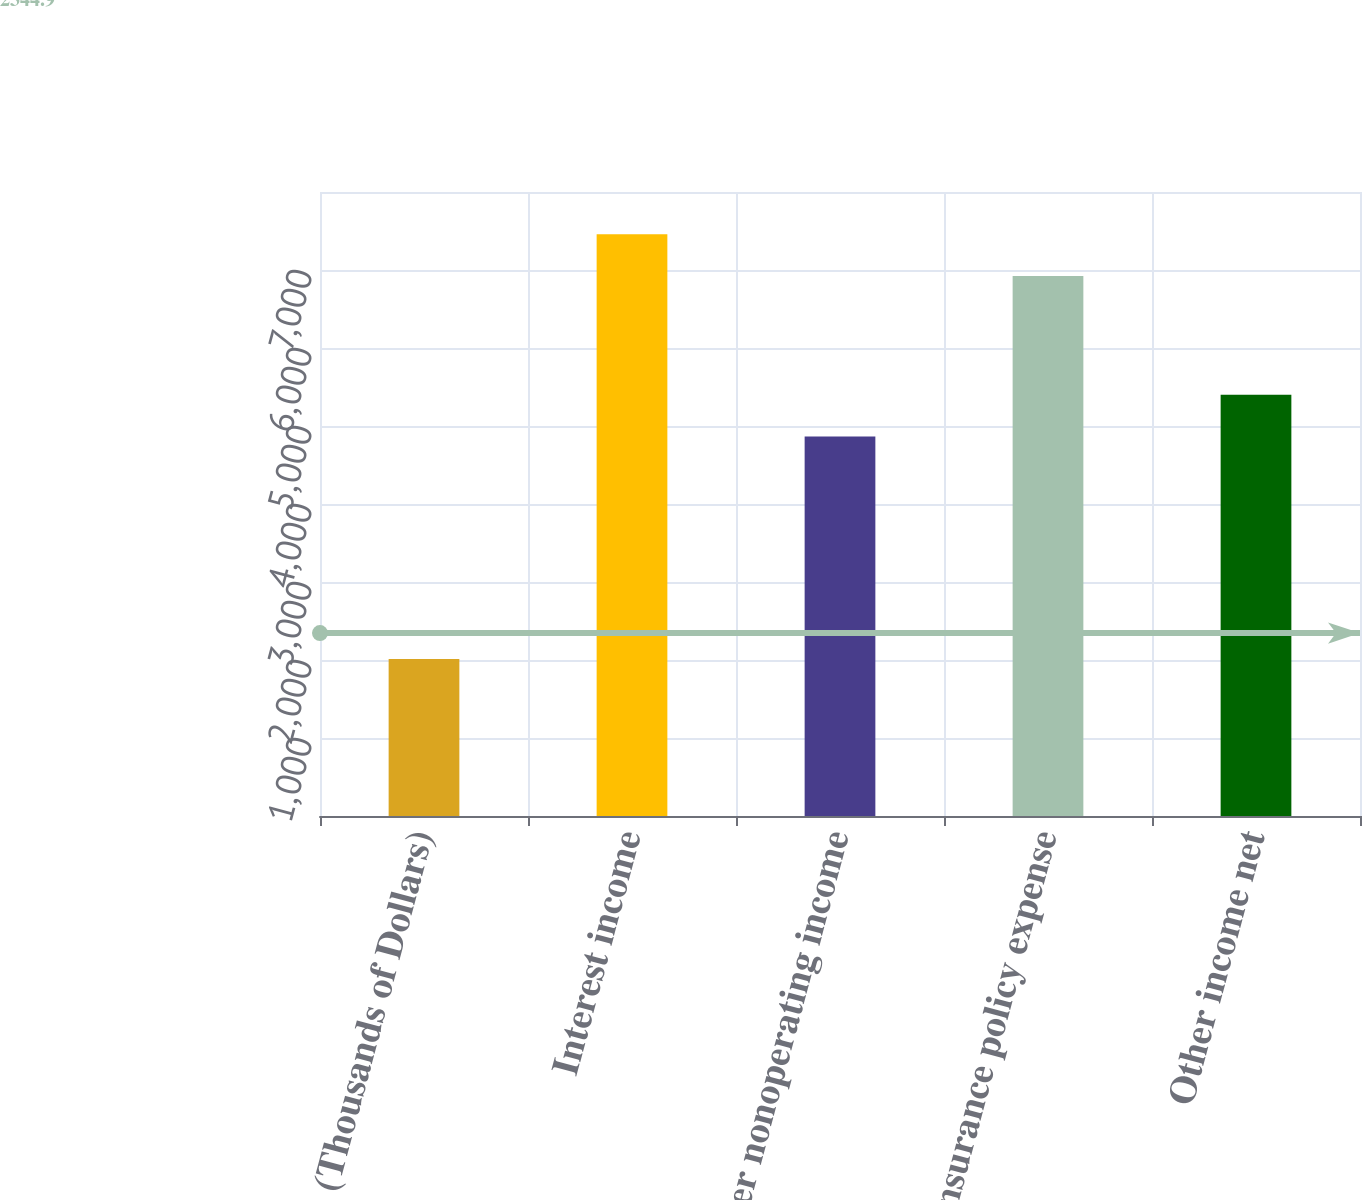Convert chart to OTSL. <chart><loc_0><loc_0><loc_500><loc_500><bar_chart><fcel>(Thousands of Dollars)<fcel>Interest income<fcel>Other nonoperating income<fcel>Insurance policy expense<fcel>Other income net<nl><fcel>2014<fcel>7456.9<fcel>4866<fcel>6923<fcel>5399.9<nl></chart> 